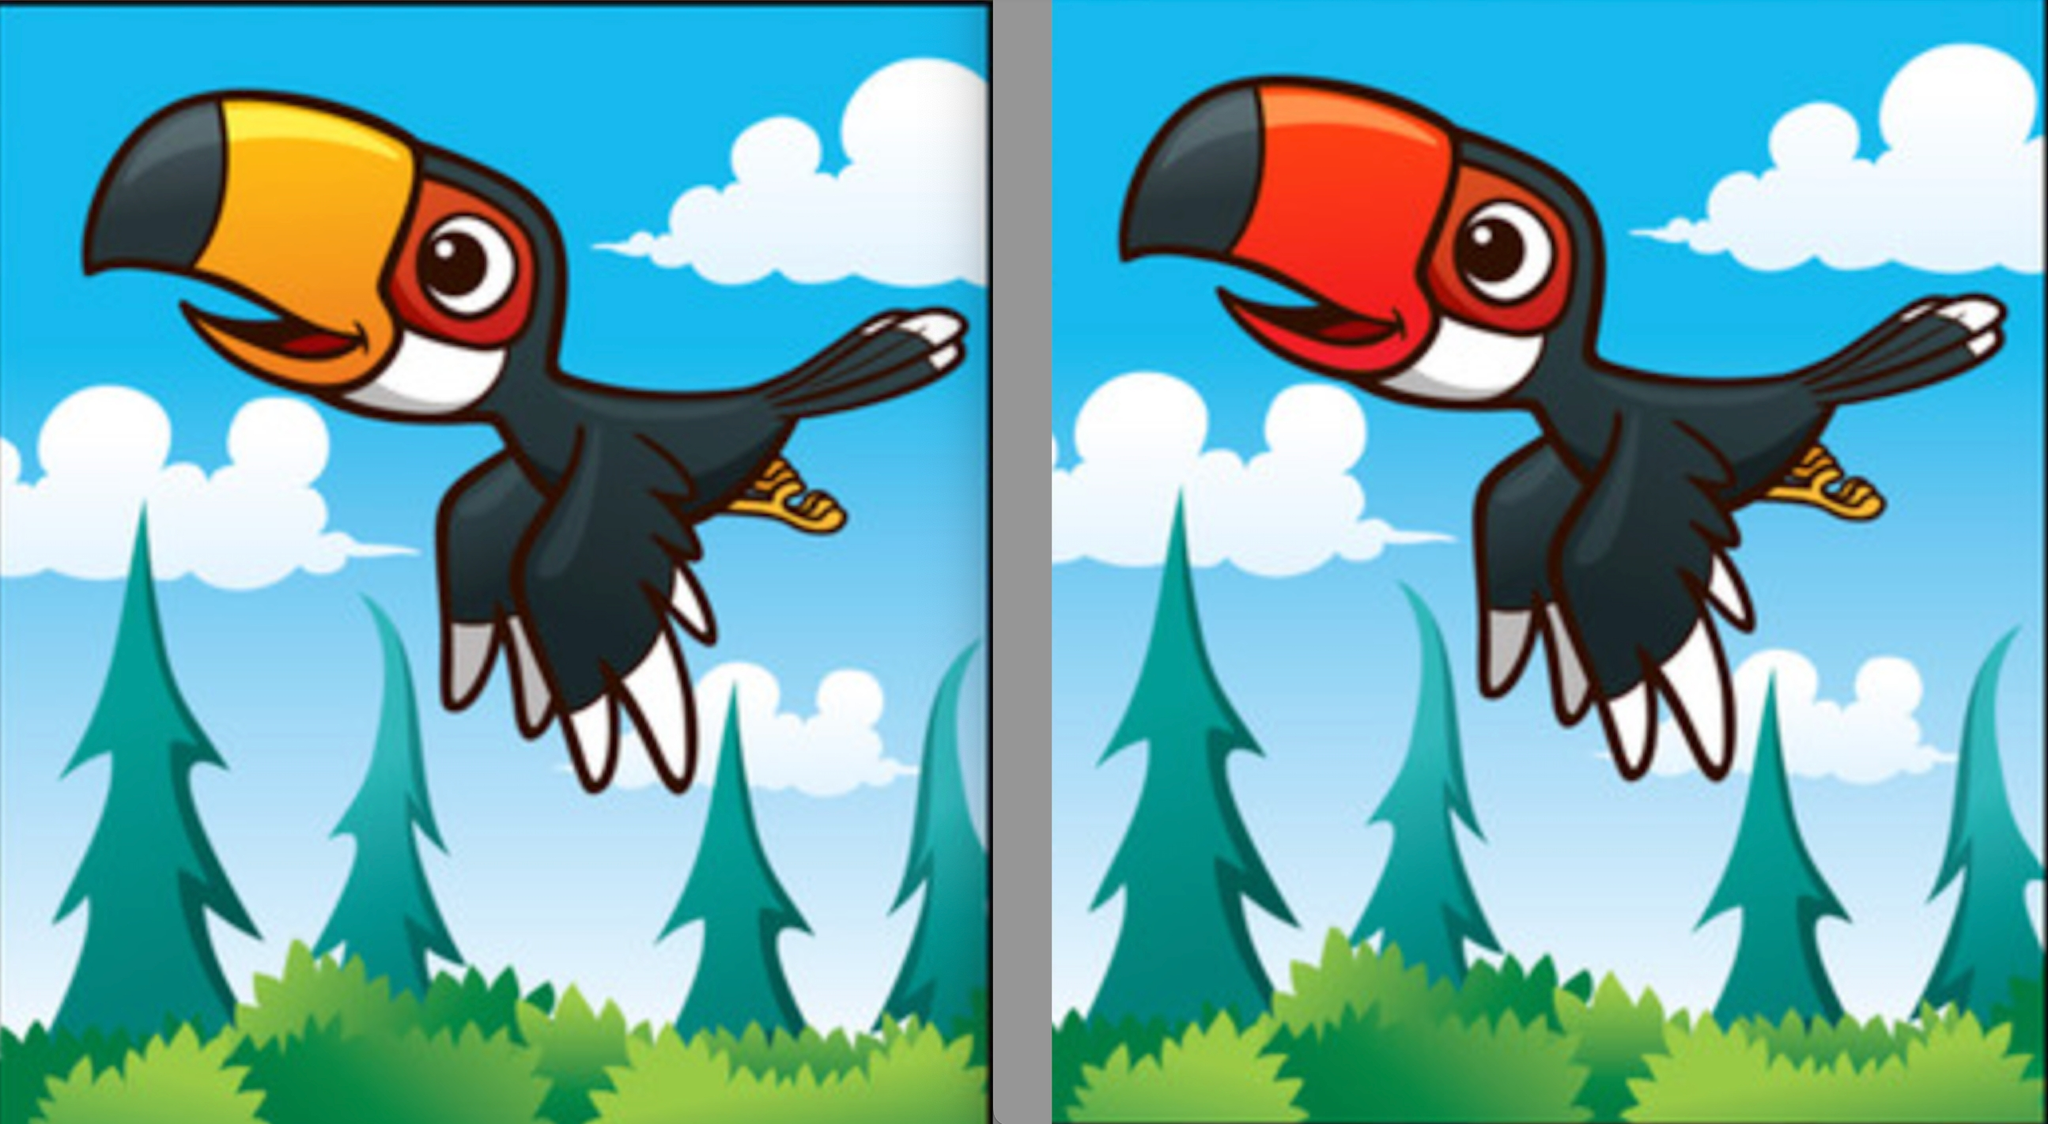详细描述下做哟两张图片的内容，不少于200字，然后找出所有的不同点
 这两张图片展示了一只卡通风格的飞翔中的鸟。这只鸟的主要颜色是黑色，拥有白色的喉部和腹部，红色的眼睛和黄色的爪子。图片的背景是蓝天和绿色的森林，天上点缀着几朵白色的云朵，森林由几棵高大的松树和低矮的灌木组成。

鸟的嘴巴形状很大，分为黑色和橙色两部分。鸟的翅膀在飞翔中展开，尾羽向后延展，显示出飞行的动态。鸟的爪子紧紧抓住一根树枝，看起来非常有活力。

虽然这两张图片看起来非常相似，但它们之间有一些细微的差异。以下是找出的所有不同点：

1. 嘴巴颜色：
   - 左边图片中，鸟的嘴巴是橙色。
   - 右边图片中，鸟的嘴巴是红色。

2. 云朵形状和位置：
   - 左边图片中的云朵形状较为圆润，且位置略有不同。
   - 右边图片中的云朵形状更为分散，有些云朵的位置也发生了变化。

3. 树的形状：
   - 左边图片中的树形状较为尖锐。
   - 右边图片中的树形状略有不同，树的尖端更为圆滑。

4. 鸟的爪子：
   - 左边图片中，鸟的右爪子间有一个明显的分叉。
   - 右边图片中，这个分叉不明显。

5. 翅膀细节：
   - 左边图片中，鸟的翅膀内侧有一条白色的线条。
   - 右边图片中，这条白色的线条没有出现。

通过对比这两张图片，可以发现这些细微的差异，使得两张图片在细节上有了一些不同，增加了观察的趣味性。 